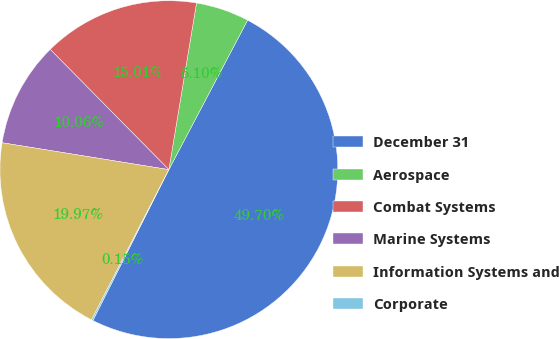Convert chart to OTSL. <chart><loc_0><loc_0><loc_500><loc_500><pie_chart><fcel>December 31<fcel>Aerospace<fcel>Combat Systems<fcel>Marine Systems<fcel>Information Systems and<fcel>Corporate<nl><fcel>49.7%<fcel>5.1%<fcel>15.01%<fcel>10.06%<fcel>19.97%<fcel>0.15%<nl></chart> 